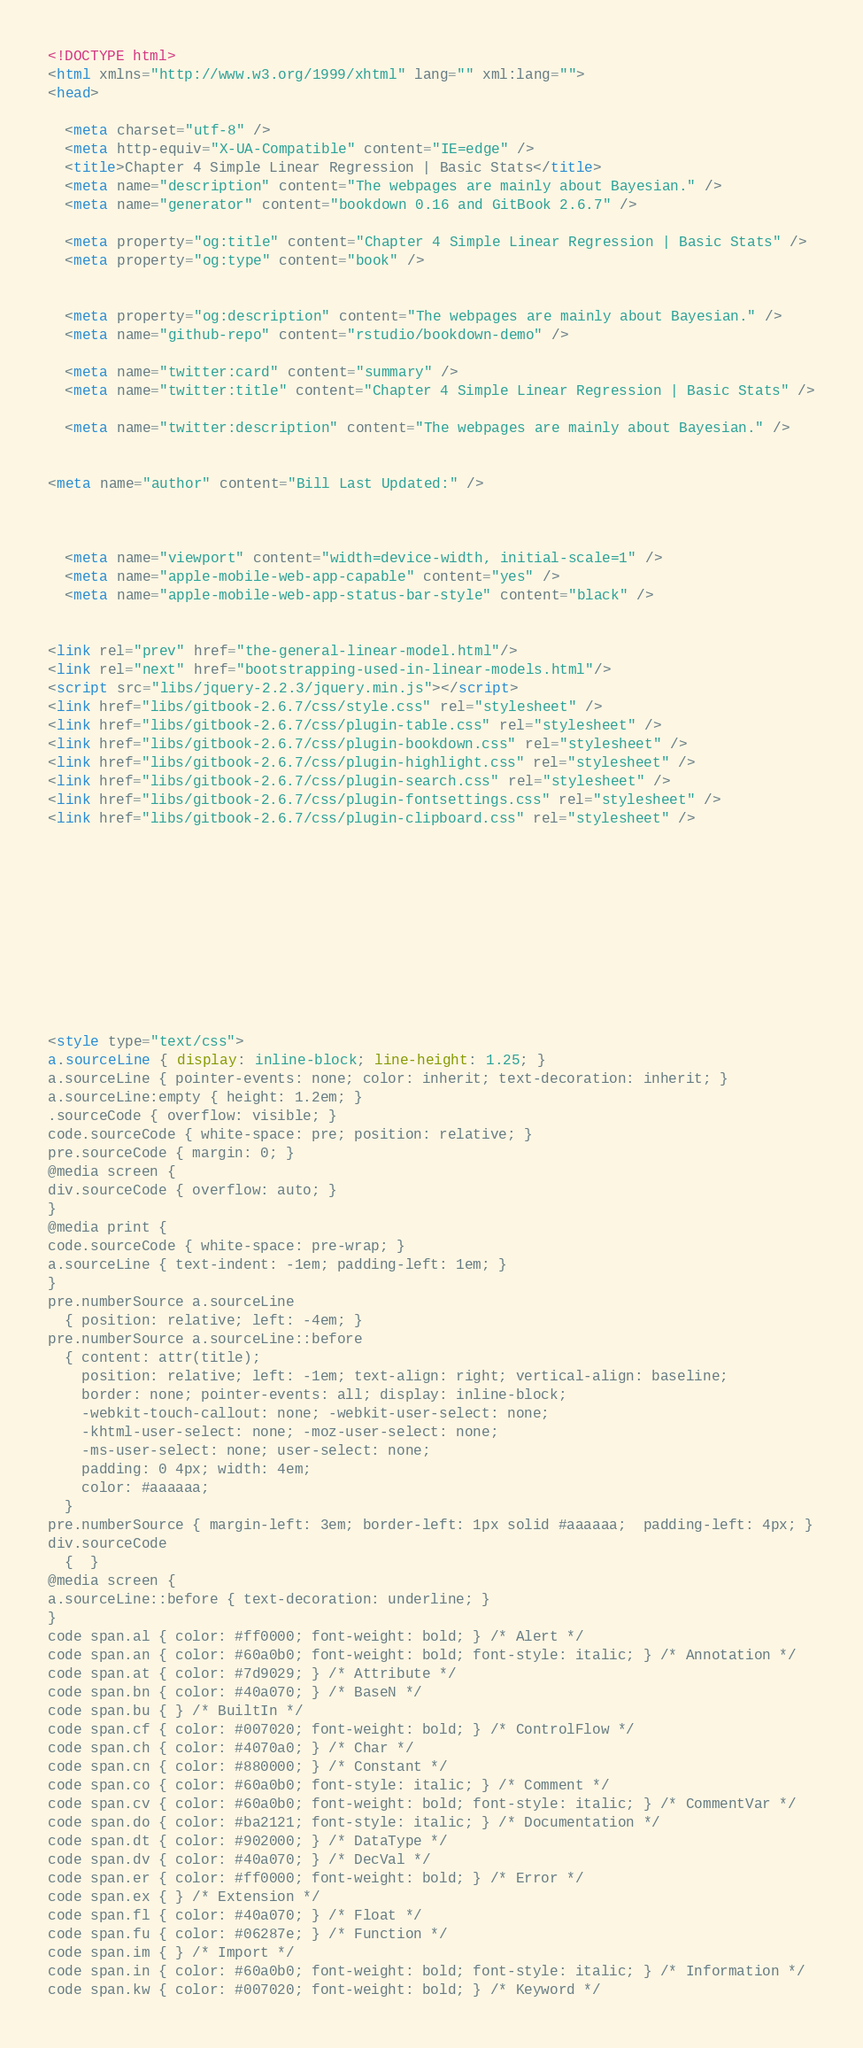Convert code to text. <code><loc_0><loc_0><loc_500><loc_500><_HTML_><!DOCTYPE html>
<html xmlns="http://www.w3.org/1999/xhtml" lang="" xml:lang="">
<head>

  <meta charset="utf-8" />
  <meta http-equiv="X-UA-Compatible" content="IE=edge" />
  <title>Chapter 4 Simple Linear Regression | Basic Stats</title>
  <meta name="description" content="The webpages are mainly about Bayesian." />
  <meta name="generator" content="bookdown 0.16 and GitBook 2.6.7" />

  <meta property="og:title" content="Chapter 4 Simple Linear Regression | Basic Stats" />
  <meta property="og:type" content="book" />
  
  
  <meta property="og:description" content="The webpages are mainly about Bayesian." />
  <meta name="github-repo" content="rstudio/bookdown-demo" />

  <meta name="twitter:card" content="summary" />
  <meta name="twitter:title" content="Chapter 4 Simple Linear Regression | Basic Stats" />
  
  <meta name="twitter:description" content="The webpages are mainly about Bayesian." />
  

<meta name="author" content="Bill Last Updated:" />



  <meta name="viewport" content="width=device-width, initial-scale=1" />
  <meta name="apple-mobile-web-app-capable" content="yes" />
  <meta name="apple-mobile-web-app-status-bar-style" content="black" />
  
  
<link rel="prev" href="the-general-linear-model.html"/>
<link rel="next" href="bootstrapping-used-in-linear-models.html"/>
<script src="libs/jquery-2.2.3/jquery.min.js"></script>
<link href="libs/gitbook-2.6.7/css/style.css" rel="stylesheet" />
<link href="libs/gitbook-2.6.7/css/plugin-table.css" rel="stylesheet" />
<link href="libs/gitbook-2.6.7/css/plugin-bookdown.css" rel="stylesheet" />
<link href="libs/gitbook-2.6.7/css/plugin-highlight.css" rel="stylesheet" />
<link href="libs/gitbook-2.6.7/css/plugin-search.css" rel="stylesheet" />
<link href="libs/gitbook-2.6.7/css/plugin-fontsettings.css" rel="stylesheet" />
<link href="libs/gitbook-2.6.7/css/plugin-clipboard.css" rel="stylesheet" />











<style type="text/css">
a.sourceLine { display: inline-block; line-height: 1.25; }
a.sourceLine { pointer-events: none; color: inherit; text-decoration: inherit; }
a.sourceLine:empty { height: 1.2em; }
.sourceCode { overflow: visible; }
code.sourceCode { white-space: pre; position: relative; }
pre.sourceCode { margin: 0; }
@media screen {
div.sourceCode { overflow: auto; }
}
@media print {
code.sourceCode { white-space: pre-wrap; }
a.sourceLine { text-indent: -1em; padding-left: 1em; }
}
pre.numberSource a.sourceLine
  { position: relative; left: -4em; }
pre.numberSource a.sourceLine::before
  { content: attr(title);
    position: relative; left: -1em; text-align: right; vertical-align: baseline;
    border: none; pointer-events: all; display: inline-block;
    -webkit-touch-callout: none; -webkit-user-select: none;
    -khtml-user-select: none; -moz-user-select: none;
    -ms-user-select: none; user-select: none;
    padding: 0 4px; width: 4em;
    color: #aaaaaa;
  }
pre.numberSource { margin-left: 3em; border-left: 1px solid #aaaaaa;  padding-left: 4px; }
div.sourceCode
  {  }
@media screen {
a.sourceLine::before { text-decoration: underline; }
}
code span.al { color: #ff0000; font-weight: bold; } /* Alert */
code span.an { color: #60a0b0; font-weight: bold; font-style: italic; } /* Annotation */
code span.at { color: #7d9029; } /* Attribute */
code span.bn { color: #40a070; } /* BaseN */
code span.bu { } /* BuiltIn */
code span.cf { color: #007020; font-weight: bold; } /* ControlFlow */
code span.ch { color: #4070a0; } /* Char */
code span.cn { color: #880000; } /* Constant */
code span.co { color: #60a0b0; font-style: italic; } /* Comment */
code span.cv { color: #60a0b0; font-weight: bold; font-style: italic; } /* CommentVar */
code span.do { color: #ba2121; font-style: italic; } /* Documentation */
code span.dt { color: #902000; } /* DataType */
code span.dv { color: #40a070; } /* DecVal */
code span.er { color: #ff0000; font-weight: bold; } /* Error */
code span.ex { } /* Extension */
code span.fl { color: #40a070; } /* Float */
code span.fu { color: #06287e; } /* Function */
code span.im { } /* Import */
code span.in { color: #60a0b0; font-weight: bold; font-style: italic; } /* Information */
code span.kw { color: #007020; font-weight: bold; } /* Keyword */</code> 